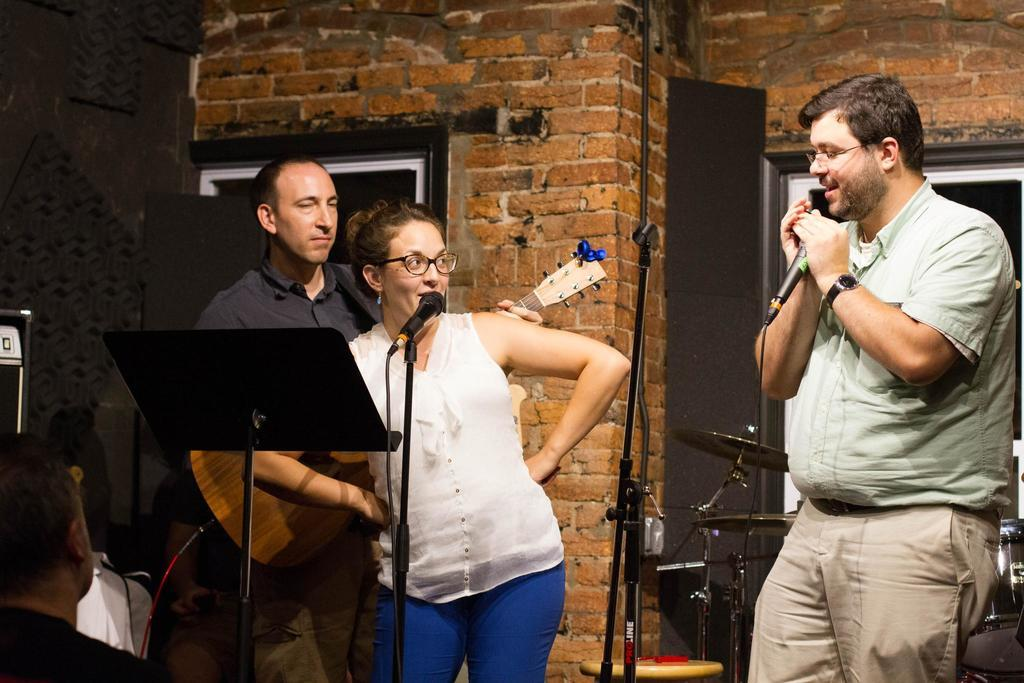What are the people in the image doing? There are people standing in the image, and some of them are holding microphones. What is the person with the guitar doing? The person holding a guitar is likely playing or preparing to play music. What is the role of the person watching the others? The person watching the others might be an audience member or a participant waiting for their turn. What type of bone can be seen in the lunchroom in the image? There is no lunchroom or bone present in the image; it features people standing and holding microphones or a guitar. 